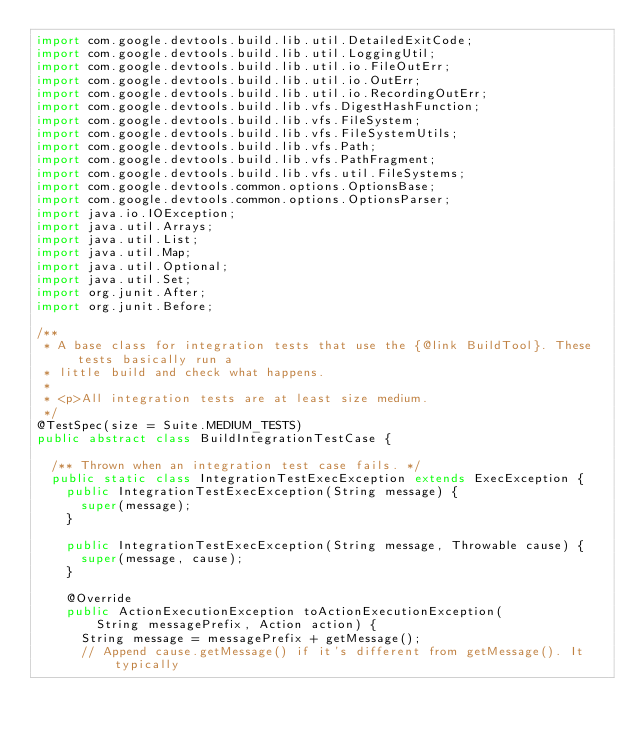<code> <loc_0><loc_0><loc_500><loc_500><_Java_>import com.google.devtools.build.lib.util.DetailedExitCode;
import com.google.devtools.build.lib.util.LoggingUtil;
import com.google.devtools.build.lib.util.io.FileOutErr;
import com.google.devtools.build.lib.util.io.OutErr;
import com.google.devtools.build.lib.util.io.RecordingOutErr;
import com.google.devtools.build.lib.vfs.DigestHashFunction;
import com.google.devtools.build.lib.vfs.FileSystem;
import com.google.devtools.build.lib.vfs.FileSystemUtils;
import com.google.devtools.build.lib.vfs.Path;
import com.google.devtools.build.lib.vfs.PathFragment;
import com.google.devtools.build.lib.vfs.util.FileSystems;
import com.google.devtools.common.options.OptionsBase;
import com.google.devtools.common.options.OptionsParser;
import java.io.IOException;
import java.util.Arrays;
import java.util.List;
import java.util.Map;
import java.util.Optional;
import java.util.Set;
import org.junit.After;
import org.junit.Before;

/**
 * A base class for integration tests that use the {@link BuildTool}. These tests basically run a
 * little build and check what happens.
 *
 * <p>All integration tests are at least size medium.
 */
@TestSpec(size = Suite.MEDIUM_TESTS)
public abstract class BuildIntegrationTestCase {

  /** Thrown when an integration test case fails. */
  public static class IntegrationTestExecException extends ExecException {
    public IntegrationTestExecException(String message) {
      super(message);
    }

    public IntegrationTestExecException(String message, Throwable cause) {
      super(message, cause);
    }

    @Override
    public ActionExecutionException toActionExecutionException(
        String messagePrefix, Action action) {
      String message = messagePrefix + getMessage();
      // Append cause.getMessage() if it's different from getMessage(). It typically</code> 